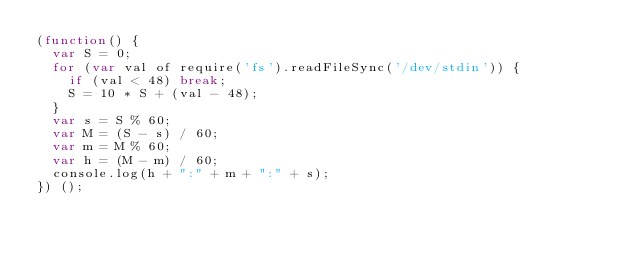<code> <loc_0><loc_0><loc_500><loc_500><_JavaScript_>(function() {
	var S = 0;
	for (var val of require('fs').readFileSync('/dev/stdin')) {
		if (val < 48) break;
		S = 10 * S + (val - 48);
	}
	var s = S % 60;
	var M = (S - s) / 60;
	var m = M % 60;
	var h = (M - m) / 60;
	console.log(h + ":" + m + ":" + s);
}) ();</code> 